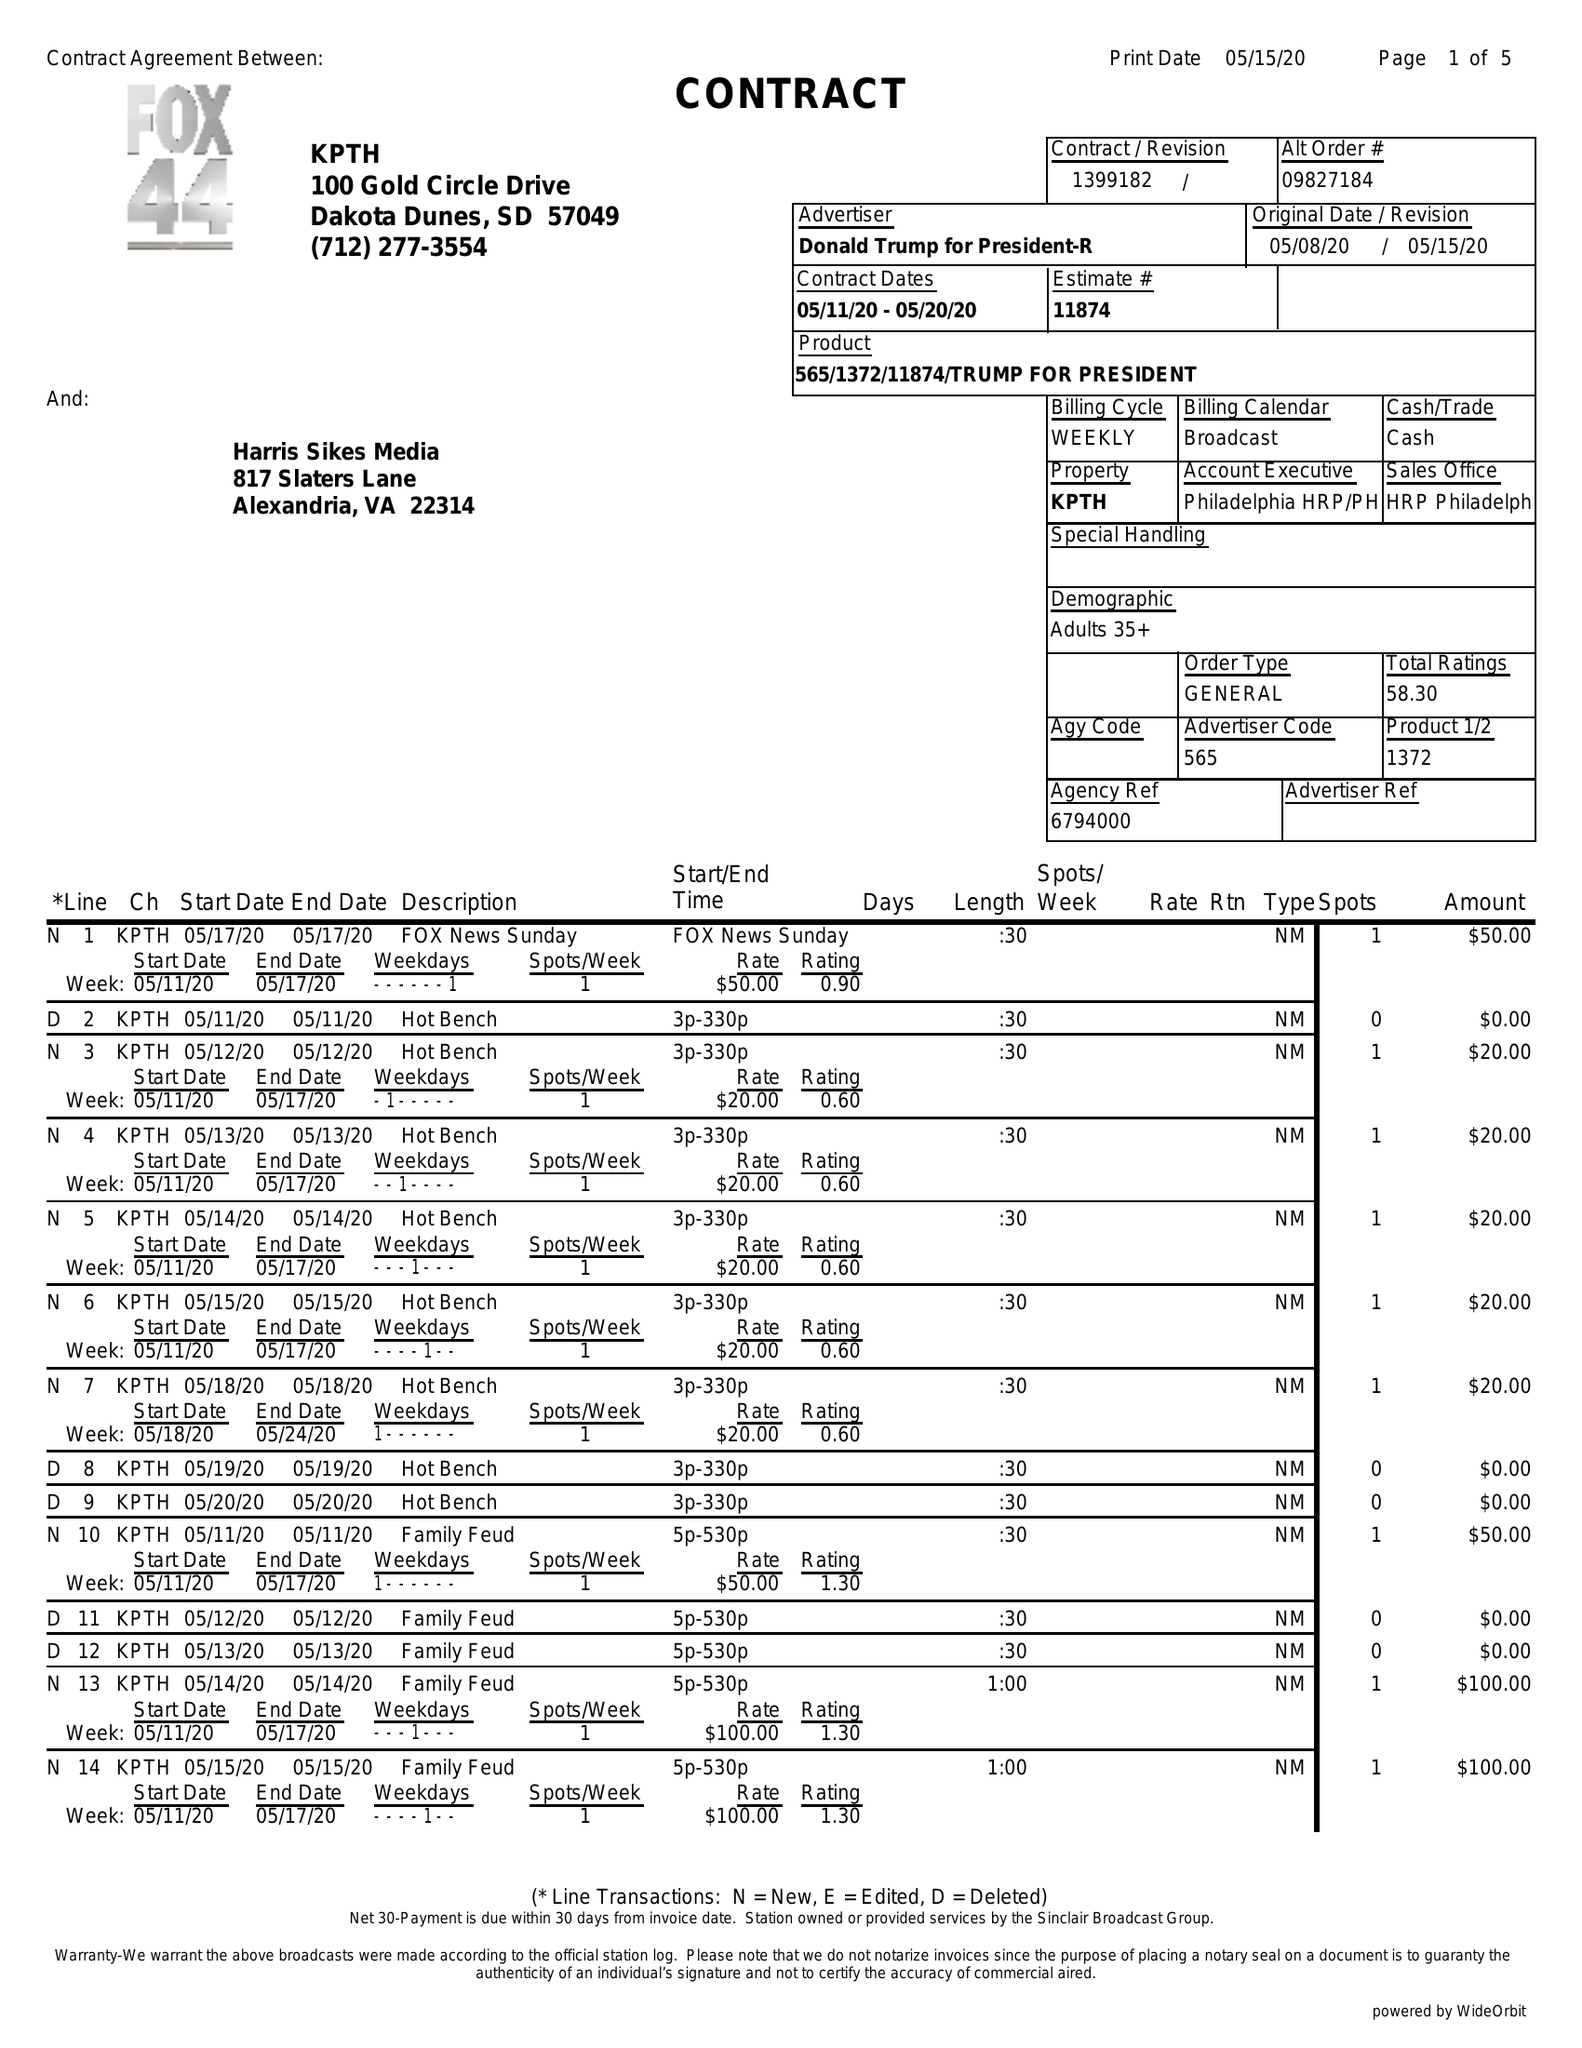What is the value for the contract_num?
Answer the question using a single word or phrase. 1399182 